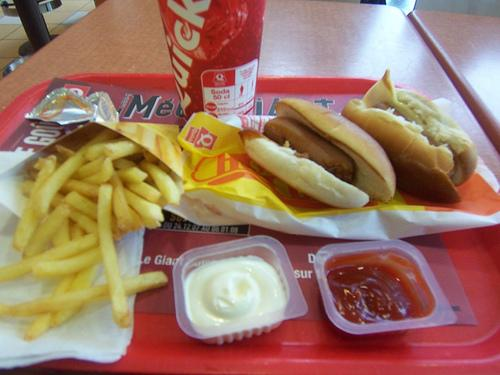What is being dipped in the red sauce? fries 